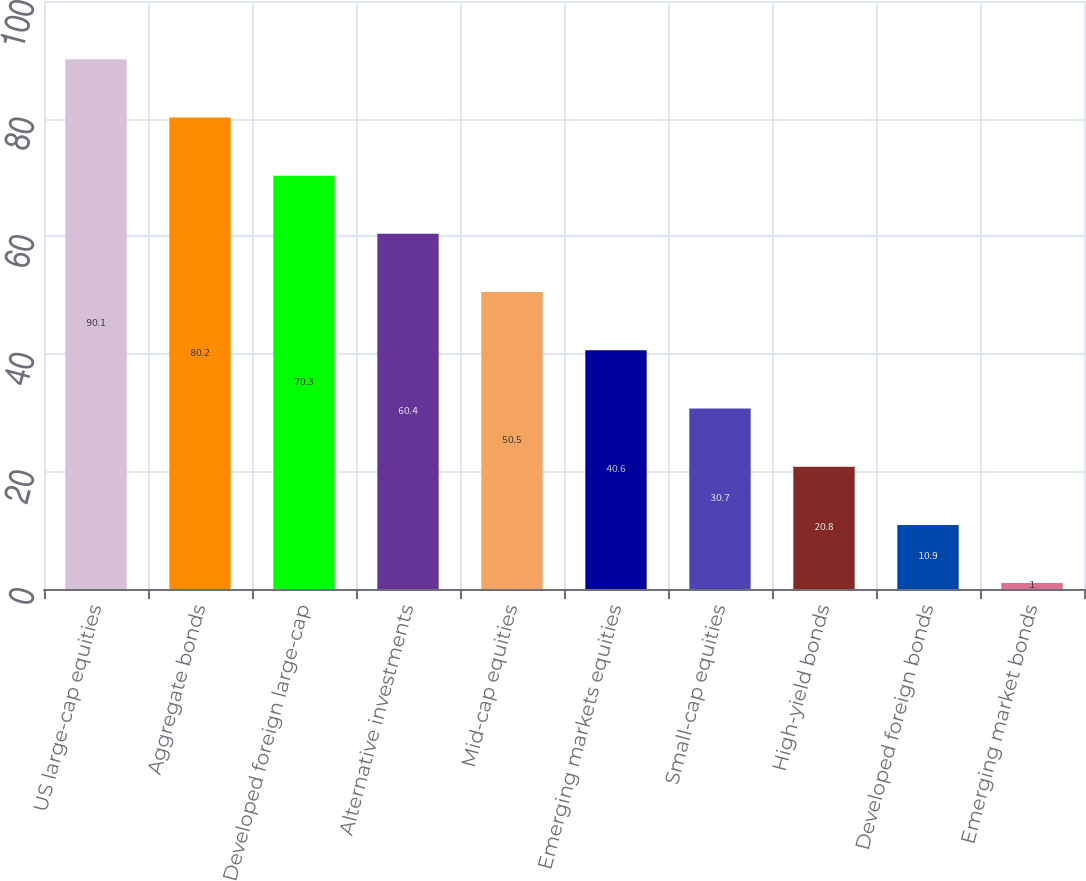Convert chart to OTSL. <chart><loc_0><loc_0><loc_500><loc_500><bar_chart><fcel>US large-cap equities<fcel>Aggregate bonds<fcel>Developed foreign large-cap<fcel>Alternative investments<fcel>Mid-cap equities<fcel>Emerging markets equities<fcel>Small-cap equities<fcel>High-yield bonds<fcel>Developed foreign bonds<fcel>Emerging market bonds<nl><fcel>90.1<fcel>80.2<fcel>70.3<fcel>60.4<fcel>50.5<fcel>40.6<fcel>30.7<fcel>20.8<fcel>10.9<fcel>1<nl></chart> 